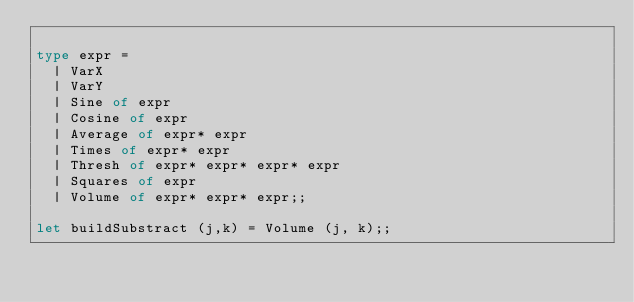Convert code to text. <code><loc_0><loc_0><loc_500><loc_500><_OCaml_>
type expr =
  | VarX
  | VarY
  | Sine of expr
  | Cosine of expr
  | Average of expr* expr
  | Times of expr* expr
  | Thresh of expr* expr* expr* expr
  | Squares of expr
  | Volume of expr* expr* expr;;

let buildSubstract (j,k) = Volume (j, k);;
</code> 